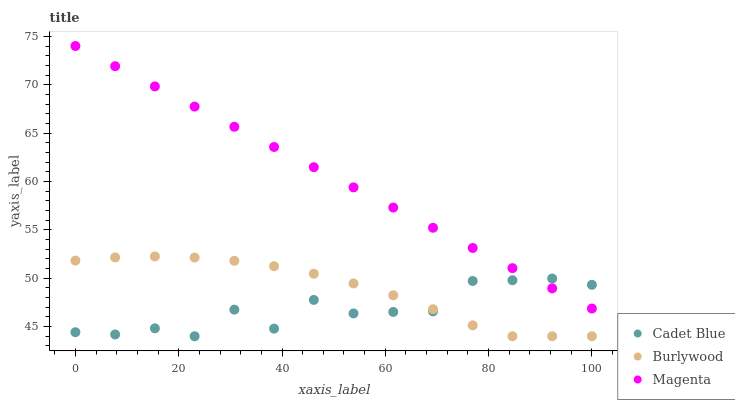Does Cadet Blue have the minimum area under the curve?
Answer yes or no. Yes. Does Magenta have the maximum area under the curve?
Answer yes or no. Yes. Does Magenta have the minimum area under the curve?
Answer yes or no. No. Does Cadet Blue have the maximum area under the curve?
Answer yes or no. No. Is Magenta the smoothest?
Answer yes or no. Yes. Is Cadet Blue the roughest?
Answer yes or no. Yes. Is Cadet Blue the smoothest?
Answer yes or no. No. Is Magenta the roughest?
Answer yes or no. No. Does Burlywood have the lowest value?
Answer yes or no. Yes. Does Magenta have the lowest value?
Answer yes or no. No. Does Magenta have the highest value?
Answer yes or no. Yes. Does Cadet Blue have the highest value?
Answer yes or no. No. Is Burlywood less than Magenta?
Answer yes or no. Yes. Is Magenta greater than Burlywood?
Answer yes or no. Yes. Does Cadet Blue intersect Magenta?
Answer yes or no. Yes. Is Cadet Blue less than Magenta?
Answer yes or no. No. Is Cadet Blue greater than Magenta?
Answer yes or no. No. Does Burlywood intersect Magenta?
Answer yes or no. No. 